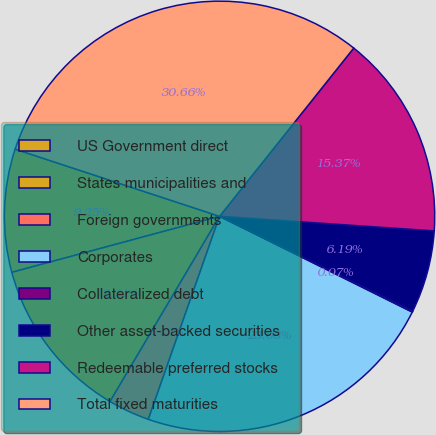<chart> <loc_0><loc_0><loc_500><loc_500><pie_chart><fcel>US Government direct<fcel>States municipalities and<fcel>Foreign governments<fcel>Corporates<fcel>Collateralized debt<fcel>Other asset-backed securities<fcel>Redeemable preferred stocks<fcel>Total fixed maturities<nl><fcel>9.25%<fcel>12.31%<fcel>3.13%<fcel>23.04%<fcel>0.07%<fcel>6.19%<fcel>15.37%<fcel>30.67%<nl></chart> 